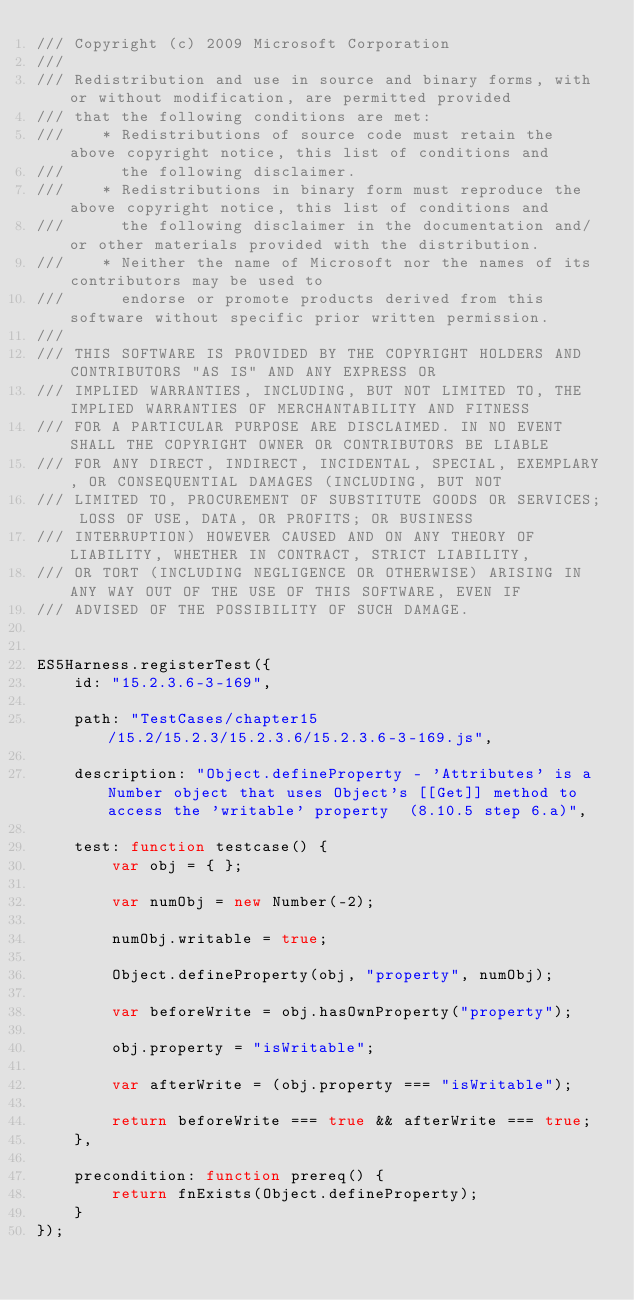Convert code to text. <code><loc_0><loc_0><loc_500><loc_500><_JavaScript_>/// Copyright (c) 2009 Microsoft Corporation 
/// 
/// Redistribution and use in source and binary forms, with or without modification, are permitted provided
/// that the following conditions are met: 
///    * Redistributions of source code must retain the above copyright notice, this list of conditions and
///      the following disclaimer. 
///    * Redistributions in binary form must reproduce the above copyright notice, this list of conditions and 
///      the following disclaimer in the documentation and/or other materials provided with the distribution.  
///    * Neither the name of Microsoft nor the names of its contributors may be used to
///      endorse or promote products derived from this software without specific prior written permission.
/// 
/// THIS SOFTWARE IS PROVIDED BY THE COPYRIGHT HOLDERS AND CONTRIBUTORS "AS IS" AND ANY EXPRESS OR
/// IMPLIED WARRANTIES, INCLUDING, BUT NOT LIMITED TO, THE IMPLIED WARRANTIES OF MERCHANTABILITY AND FITNESS
/// FOR A PARTICULAR PURPOSE ARE DISCLAIMED. IN NO EVENT SHALL THE COPYRIGHT OWNER OR CONTRIBUTORS BE LIABLE
/// FOR ANY DIRECT, INDIRECT, INCIDENTAL, SPECIAL, EXEMPLARY, OR CONSEQUENTIAL DAMAGES (INCLUDING, BUT NOT
/// LIMITED TO, PROCUREMENT OF SUBSTITUTE GOODS OR SERVICES; LOSS OF USE, DATA, OR PROFITS; OR BUSINESS
/// INTERRUPTION) HOWEVER CAUSED AND ON ANY THEORY OF LIABILITY, WHETHER IN CONTRACT, STRICT LIABILITY,
/// OR TORT (INCLUDING NEGLIGENCE OR OTHERWISE) ARISING IN ANY WAY OUT OF THE USE OF THIS SOFTWARE, EVEN IF
/// ADVISED OF THE POSSIBILITY OF SUCH DAMAGE. 


ES5Harness.registerTest({
    id: "15.2.3.6-3-169",

    path: "TestCases/chapter15/15.2/15.2.3/15.2.3.6/15.2.3.6-3-169.js",

    description: "Object.defineProperty - 'Attributes' is a Number object that uses Object's [[Get]] method to access the 'writable' property  (8.10.5 step 6.a)",

    test: function testcase() {
        var obj = { };

        var numObj = new Number(-2);

        numObj.writable = true;

        Object.defineProperty(obj, "property", numObj);

        var beforeWrite = obj.hasOwnProperty("property");

        obj.property = "isWritable";

        var afterWrite = (obj.property === "isWritable");

        return beforeWrite === true && afterWrite === true;
    },

    precondition: function prereq() {
        return fnExists(Object.defineProperty);
    }
});
</code> 